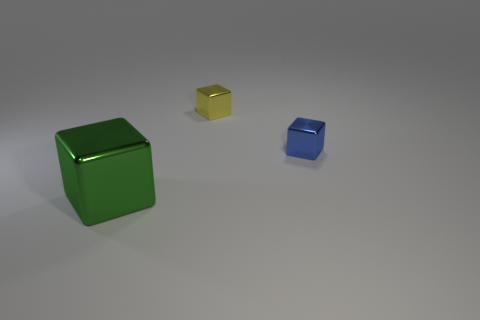What is the green object made of?
Your answer should be compact. Metal. Do the yellow block and the big block have the same material?
Provide a short and direct response. Yes. How many matte things are either tiny yellow things or blocks?
Offer a terse response. 0. What shape is the tiny shiny object that is to the right of the yellow shiny block?
Give a very brief answer. Cube. What size is the blue block that is the same material as the tiny yellow object?
Ensure brevity in your answer.  Small. There is a metal object that is both right of the green cube and to the left of the small blue shiny thing; what shape is it?
Offer a terse response. Cube. Does the small shiny cube in front of the yellow block have the same color as the large cube?
Keep it short and to the point. No. There is a metal object that is behind the blue block; is its shape the same as the shiny thing that is in front of the blue shiny object?
Your answer should be very brief. Yes. What is the size of the metal thing that is behind the blue cube?
Your response must be concise. Small. There is a block that is in front of the blue object that is in front of the small yellow block; how big is it?
Keep it short and to the point. Large. 